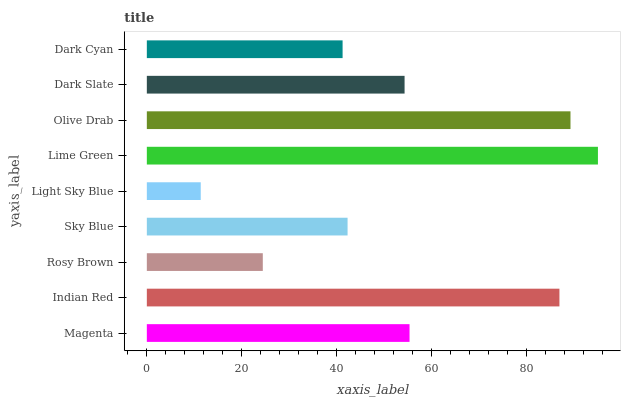Is Light Sky Blue the minimum?
Answer yes or no. Yes. Is Lime Green the maximum?
Answer yes or no. Yes. Is Indian Red the minimum?
Answer yes or no. No. Is Indian Red the maximum?
Answer yes or no. No. Is Indian Red greater than Magenta?
Answer yes or no. Yes. Is Magenta less than Indian Red?
Answer yes or no. Yes. Is Magenta greater than Indian Red?
Answer yes or no. No. Is Indian Red less than Magenta?
Answer yes or no. No. Is Dark Slate the high median?
Answer yes or no. Yes. Is Dark Slate the low median?
Answer yes or no. Yes. Is Lime Green the high median?
Answer yes or no. No. Is Light Sky Blue the low median?
Answer yes or no. No. 